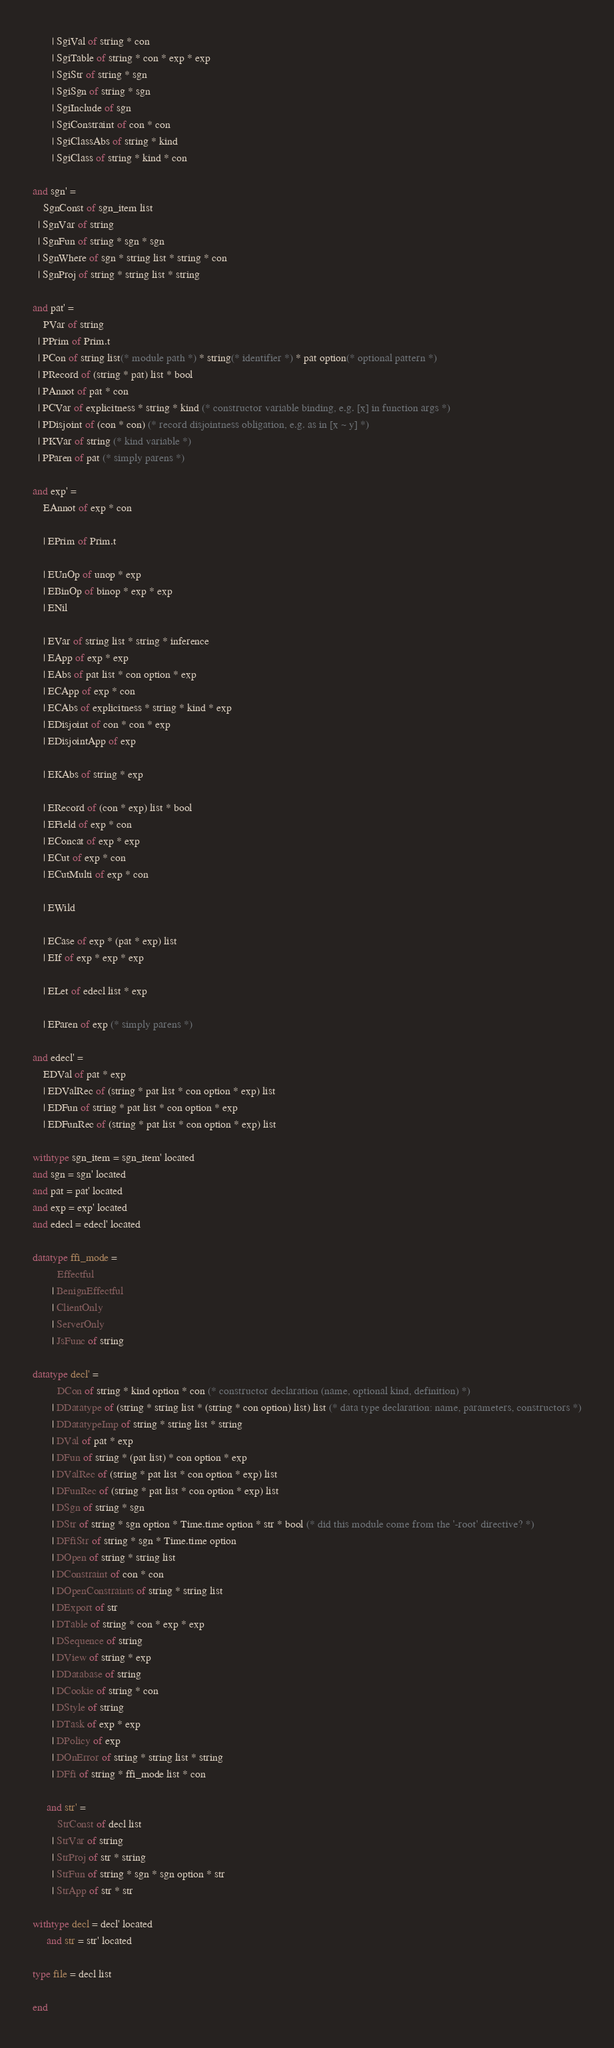Convert code to text. <code><loc_0><loc_0><loc_500><loc_500><_SML_>       | SgiVal of string * con
       | SgiTable of string * con * exp * exp
       | SgiStr of string * sgn
       | SgiSgn of string * sgn
       | SgiInclude of sgn
       | SgiConstraint of con * con
       | SgiClassAbs of string * kind
       | SgiClass of string * kind * con

and sgn' =
    SgnConst of sgn_item list
  | SgnVar of string
  | SgnFun of string * sgn * sgn
  | SgnWhere of sgn * string list * string * con
  | SgnProj of string * string list * string

and pat' =
    PVar of string
  | PPrim of Prim.t
  | PCon of string list(* module path *) * string(* identifier *) * pat option(* optional pattern *)
  | PRecord of (string * pat) list * bool
  | PAnnot of pat * con
  | PCVar of explicitness * string * kind (* constructor variable binding, e.g. [x] in function args *)
  | PDisjoint of (con * con) (* record disjointness obligation, e.g. as in [x ~ y] *)
  | PKVar of string (* kind variable *)
  | PParen of pat (* simply parens *)

and exp' =
    EAnnot of exp * con

    | EPrim of Prim.t

    | EUnOp of unop * exp
    | EBinOp of binop * exp * exp
    | ENil

    | EVar of string list * string * inference
    | EApp of exp * exp
    | EAbs of pat list * con option * exp
    | ECApp of exp * con
    | ECAbs of explicitness * string * kind * exp
    | EDisjoint of con * con * exp
    | EDisjointApp of exp

    | EKAbs of string * exp

    | ERecord of (con * exp) list * bool
    | EField of exp * con
    | EConcat of exp * exp
    | ECut of exp * con
    | ECutMulti of exp * con

    | EWild

    | ECase of exp * (pat * exp) list
    | EIf of exp * exp * exp

    | ELet of edecl list * exp

    | EParen of exp (* simply parens *)

and edecl' =
    EDVal of pat * exp
    | EDValRec of (string * pat list * con option * exp) list
    | EDFun of string * pat list * con option * exp
    | EDFunRec of (string * pat list * con option * exp) list

withtype sgn_item = sgn_item' located
and sgn = sgn' located
and pat = pat' located
and exp = exp' located
and edecl = edecl' located

datatype ffi_mode =
         Effectful
       | BenignEffectful
       | ClientOnly
       | ServerOnly
       | JsFunc of string

datatype decl' =
         DCon of string * kind option * con (* constructor declaration (name, optional kind, definition) *)
       | DDatatype of (string * string list * (string * con option) list) list (* data type declaration: name, parameters, constructors *)
       | DDatatypeImp of string * string list * string
       | DVal of pat * exp
       | DFun of string * (pat list) * con option * exp
       | DValRec of (string * pat list * con option * exp) list
       | DFunRec of (string * pat list * con option * exp) list
       | DSgn of string * sgn
       | DStr of string * sgn option * Time.time option * str * bool (* did this module come from the '-root' directive? *)
       | DFfiStr of string * sgn * Time.time option
       | DOpen of string * string list
       | DConstraint of con * con
       | DOpenConstraints of string * string list
       | DExport of str
       | DTable of string * con * exp * exp
       | DSequence of string
       | DView of string * exp
       | DDatabase of string
       | DCookie of string * con
       | DStyle of string
       | DTask of exp * exp
       | DPolicy of exp
       | DOnError of string * string list * string
       | DFfi of string * ffi_mode list * con

     and str' =
         StrConst of decl list
       | StrVar of string
       | StrProj of str * string
       | StrFun of string * sgn * sgn option * str
       | StrApp of str * str

withtype decl = decl' located
     and str = str' located

type file = decl list

end
</code> 